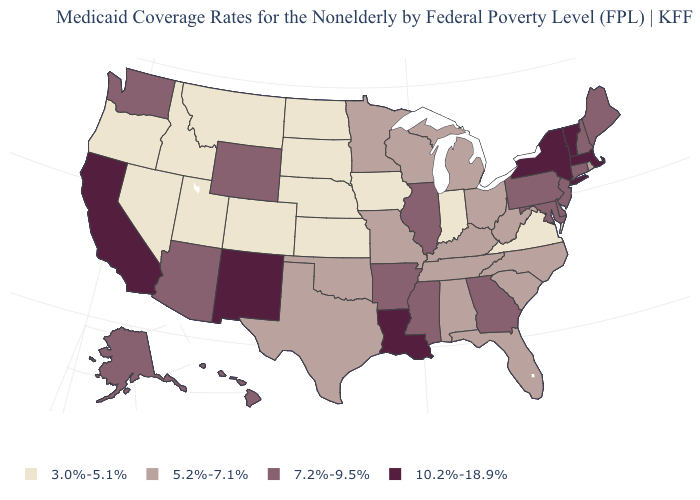What is the value of North Carolina?
Quick response, please. 5.2%-7.1%. What is the value of Mississippi?
Concise answer only. 7.2%-9.5%. What is the highest value in the USA?
Write a very short answer. 10.2%-18.9%. How many symbols are there in the legend?
Be succinct. 4. Does the map have missing data?
Concise answer only. No. Among the states that border Montana , which have the lowest value?
Give a very brief answer. Idaho, North Dakota, South Dakota. What is the highest value in the MidWest ?
Be succinct. 7.2%-9.5%. Does the first symbol in the legend represent the smallest category?
Write a very short answer. Yes. How many symbols are there in the legend?
Answer briefly. 4. Which states have the highest value in the USA?
Write a very short answer. California, Louisiana, Massachusetts, New Mexico, New York, Vermont. Which states have the lowest value in the USA?
Be succinct. Colorado, Idaho, Indiana, Iowa, Kansas, Montana, Nebraska, Nevada, North Dakota, Oregon, South Dakota, Utah, Virginia. What is the value of Montana?
Give a very brief answer. 3.0%-5.1%. What is the lowest value in the Northeast?
Short answer required. 5.2%-7.1%. How many symbols are there in the legend?
Short answer required. 4. What is the highest value in the USA?
Write a very short answer. 10.2%-18.9%. 